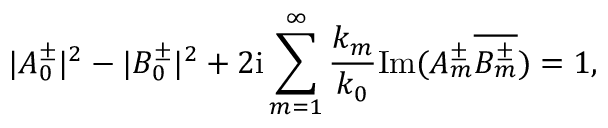Convert formula to latex. <formula><loc_0><loc_0><loc_500><loc_500>| A _ { 0 } ^ { \pm } | ^ { 2 } - | B _ { 0 } ^ { \pm } | ^ { 2 } + 2 i \sum _ { m = 1 } ^ { \infty } \frac { k _ { m } } { k _ { 0 } } I m ( A _ { m } ^ { \pm } \overline { { B _ { m } ^ { \pm } } } ) = 1 ,</formula> 